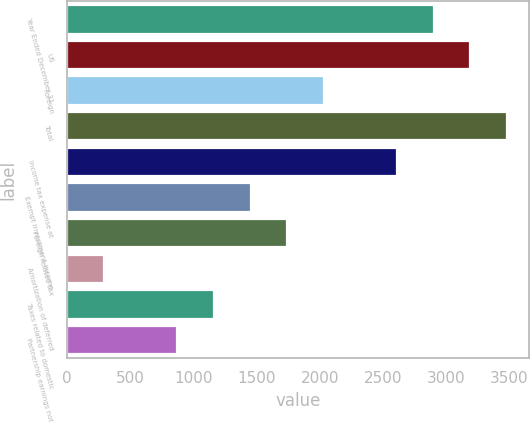Convert chart to OTSL. <chart><loc_0><loc_0><loc_500><loc_500><bar_chart><fcel>Year Ended December 31<fcel>US<fcel>Foreign<fcel>Total<fcel>Income tax expense at<fcel>Exempt investment income<fcel>Foreign related tax<fcel>Amortization of deferred<fcel>Taxes related to domestic<fcel>Partnership earnings not<nl><fcel>2902<fcel>3191.5<fcel>2033.5<fcel>3481<fcel>2612.5<fcel>1454.5<fcel>1744<fcel>296.5<fcel>1165<fcel>875.5<nl></chart> 